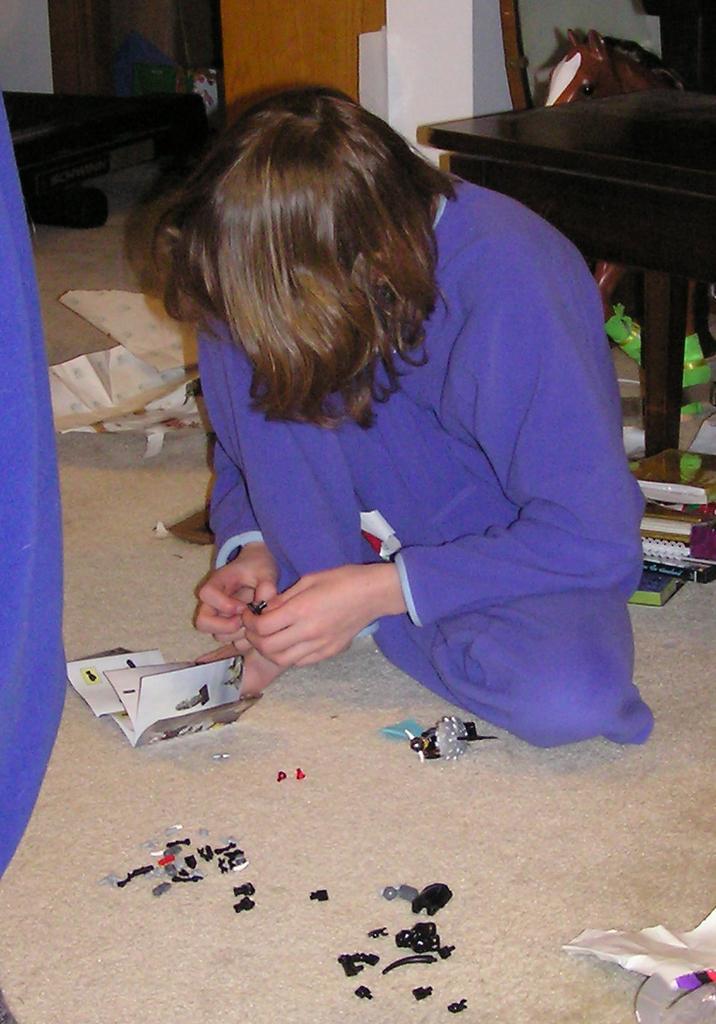Please provide a concise description of this image. In this image I can see a person wearing blue colored dress is sitting on the floor and holding a black colored object. I can see few black colored objects on the floor, few papers and few other objects. I can see a horse toy which is brown and white in color, a black colored chair, the wall and few other objects in the background. 